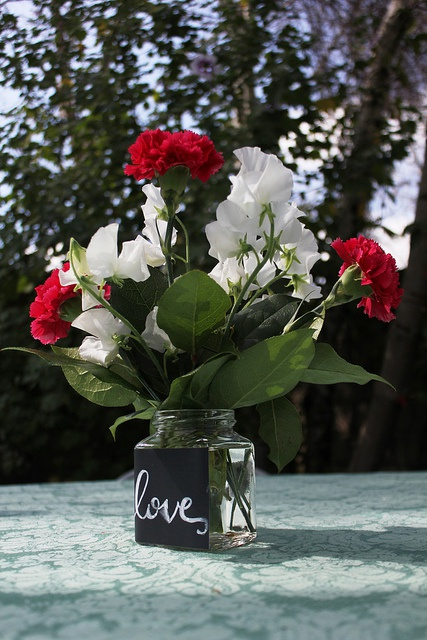Describe the objects in this image and their specific colors. I can see potted plant in lavender, black, darkgray, darkgreen, and lightgray tones and vase in lavender, black, gray, darkgray, and lightgray tones in this image. 